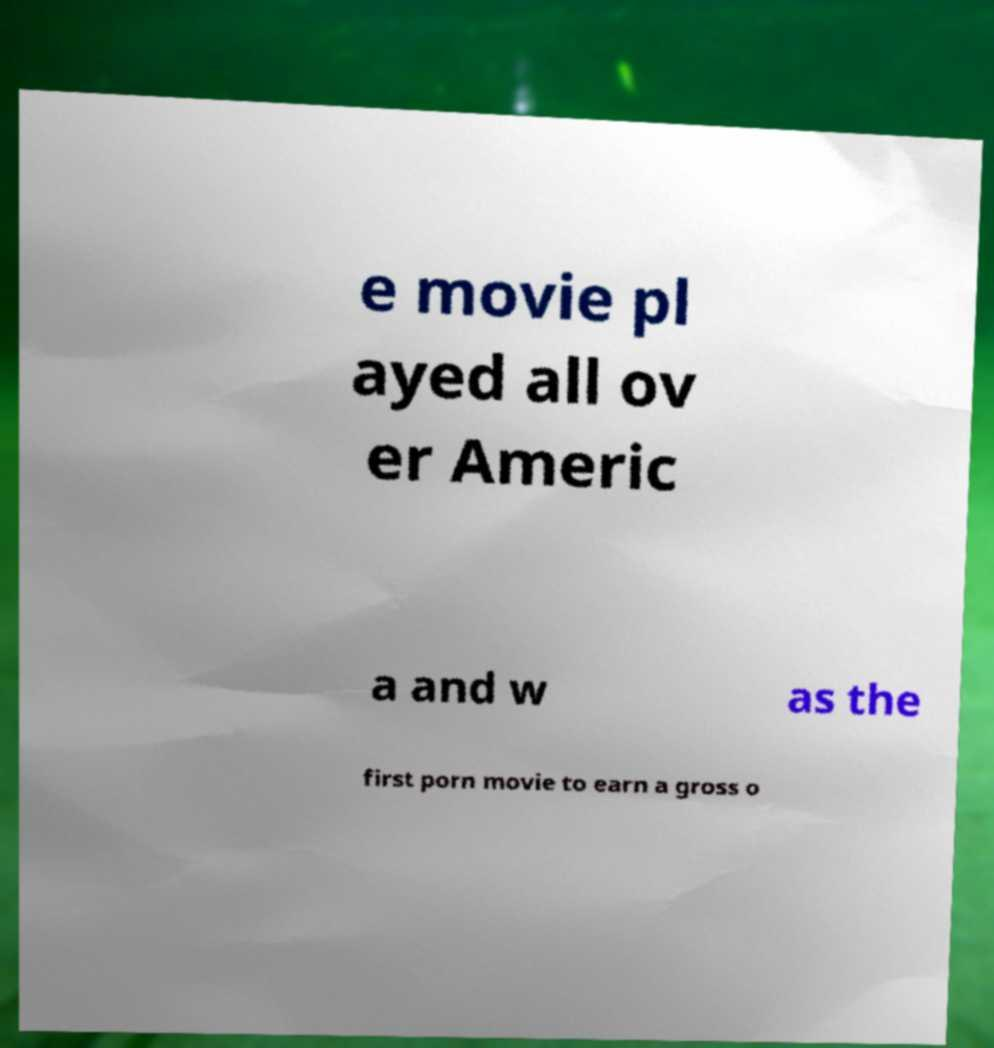Can you accurately transcribe the text from the provided image for me? e movie pl ayed all ov er Americ a and w as the first porn movie to earn a gross o 